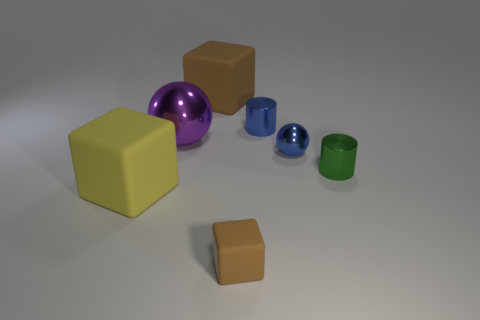What material is the large sphere?
Keep it short and to the point. Metal. What material is the brown object that is in front of the big object that is in front of the large purple ball behind the green cylinder?
Make the answer very short. Rubber. There is a brown thing that is the same size as the blue ball; what shape is it?
Your answer should be compact. Cube. How many objects are either yellow matte blocks or metal objects that are to the left of the tiny green object?
Keep it short and to the point. 4. Are the brown object in front of the blue cylinder and the big thing right of the large purple metal sphere made of the same material?
Make the answer very short. Yes. What shape is the matte thing that is the same color as the tiny rubber cube?
Offer a terse response. Cube. How many blue objects are small balls or tiny blocks?
Offer a terse response. 1. How big is the yellow matte thing?
Your answer should be compact. Large. Are there more small blue metallic cylinders that are left of the large yellow matte thing than blue matte spheres?
Offer a very short reply. No. There is a small blue sphere; what number of large yellow objects are behind it?
Provide a short and direct response. 0. 